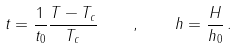Convert formula to latex. <formula><loc_0><loc_0><loc_500><loc_500>t = \frac { 1 } { t _ { 0 } } \frac { T - T _ { c } } { T _ { c } } \quad , \quad h = \frac { H } { h _ { 0 } } \, .</formula> 